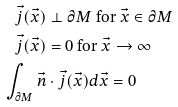<formula> <loc_0><loc_0><loc_500><loc_500>\vec { j } ( \vec { x } ) & \perp \partial M \ \text {for} \ \vec { x } \in \partial M \\ \vec { j } ( \vec { x } ) & = 0 \ \text {for} \ \vec { x } \rightarrow \infty \\ \int _ { \partial M } \vec { n } & \cdot \vec { j } ( \vec { x } ) d \vec { x } = 0</formula> 